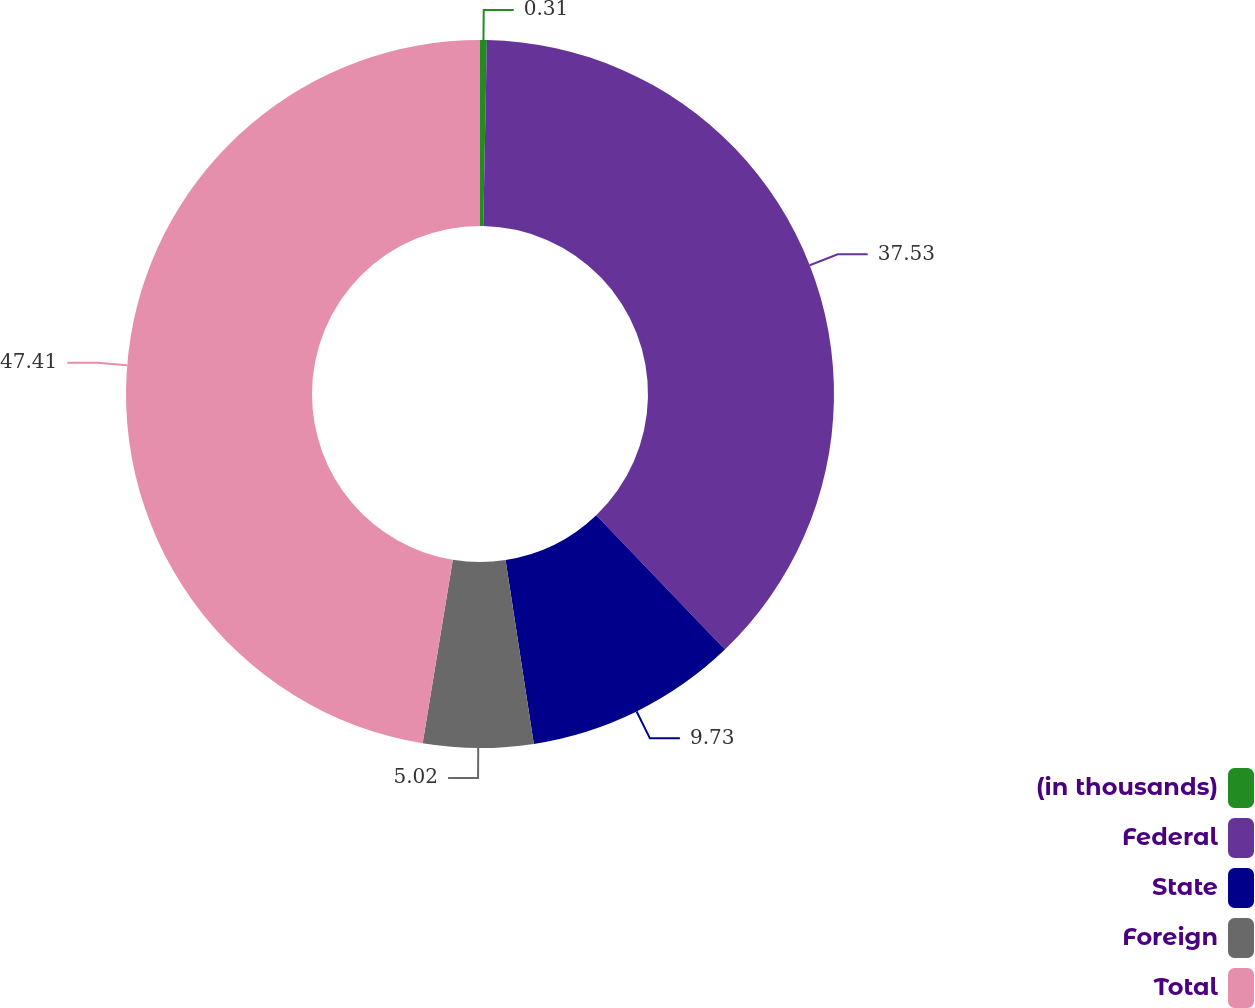<chart> <loc_0><loc_0><loc_500><loc_500><pie_chart><fcel>(in thousands)<fcel>Federal<fcel>State<fcel>Foreign<fcel>Total<nl><fcel>0.31%<fcel>37.53%<fcel>9.73%<fcel>5.02%<fcel>47.41%<nl></chart> 